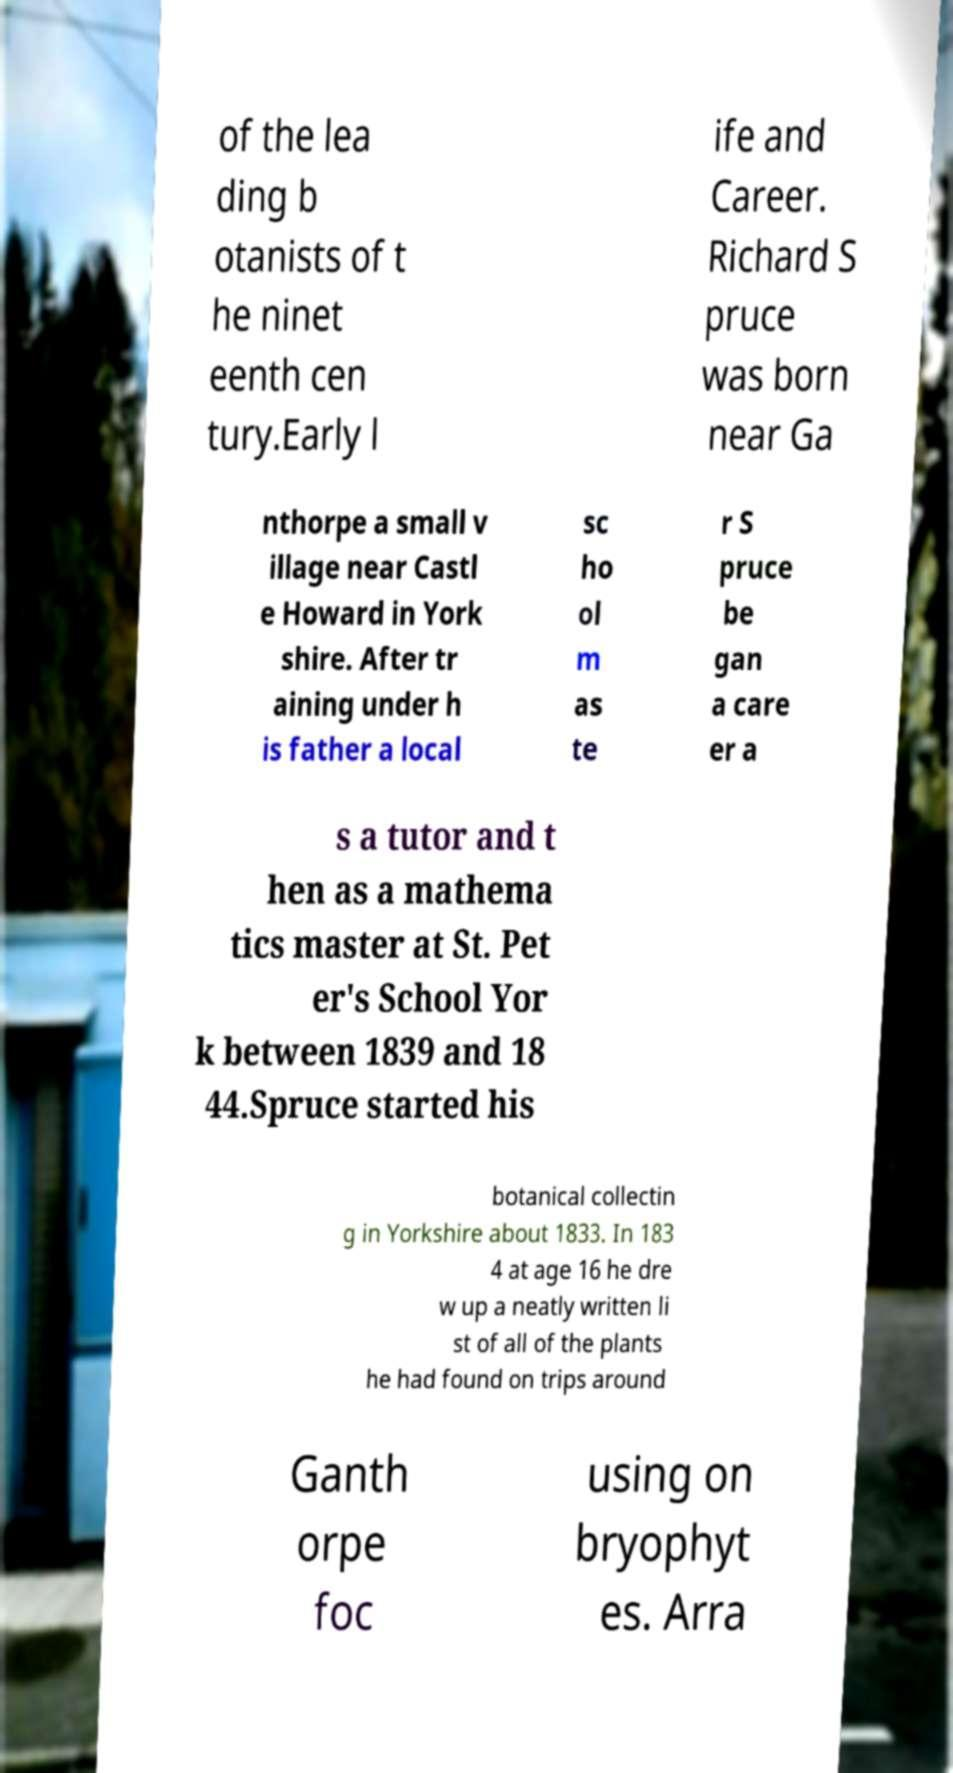For documentation purposes, I need the text within this image transcribed. Could you provide that? of the lea ding b otanists of t he ninet eenth cen tury.Early l ife and Career. Richard S pruce was born near Ga nthorpe a small v illage near Castl e Howard in York shire. After tr aining under h is father a local sc ho ol m as te r S pruce be gan a care er a s a tutor and t hen as a mathema tics master at St. Pet er's School Yor k between 1839 and 18 44.Spruce started his botanical collectin g in Yorkshire about 1833. In 183 4 at age 16 he dre w up a neatly written li st of all of the plants he had found on trips around Ganth orpe foc using on bryophyt es. Arra 